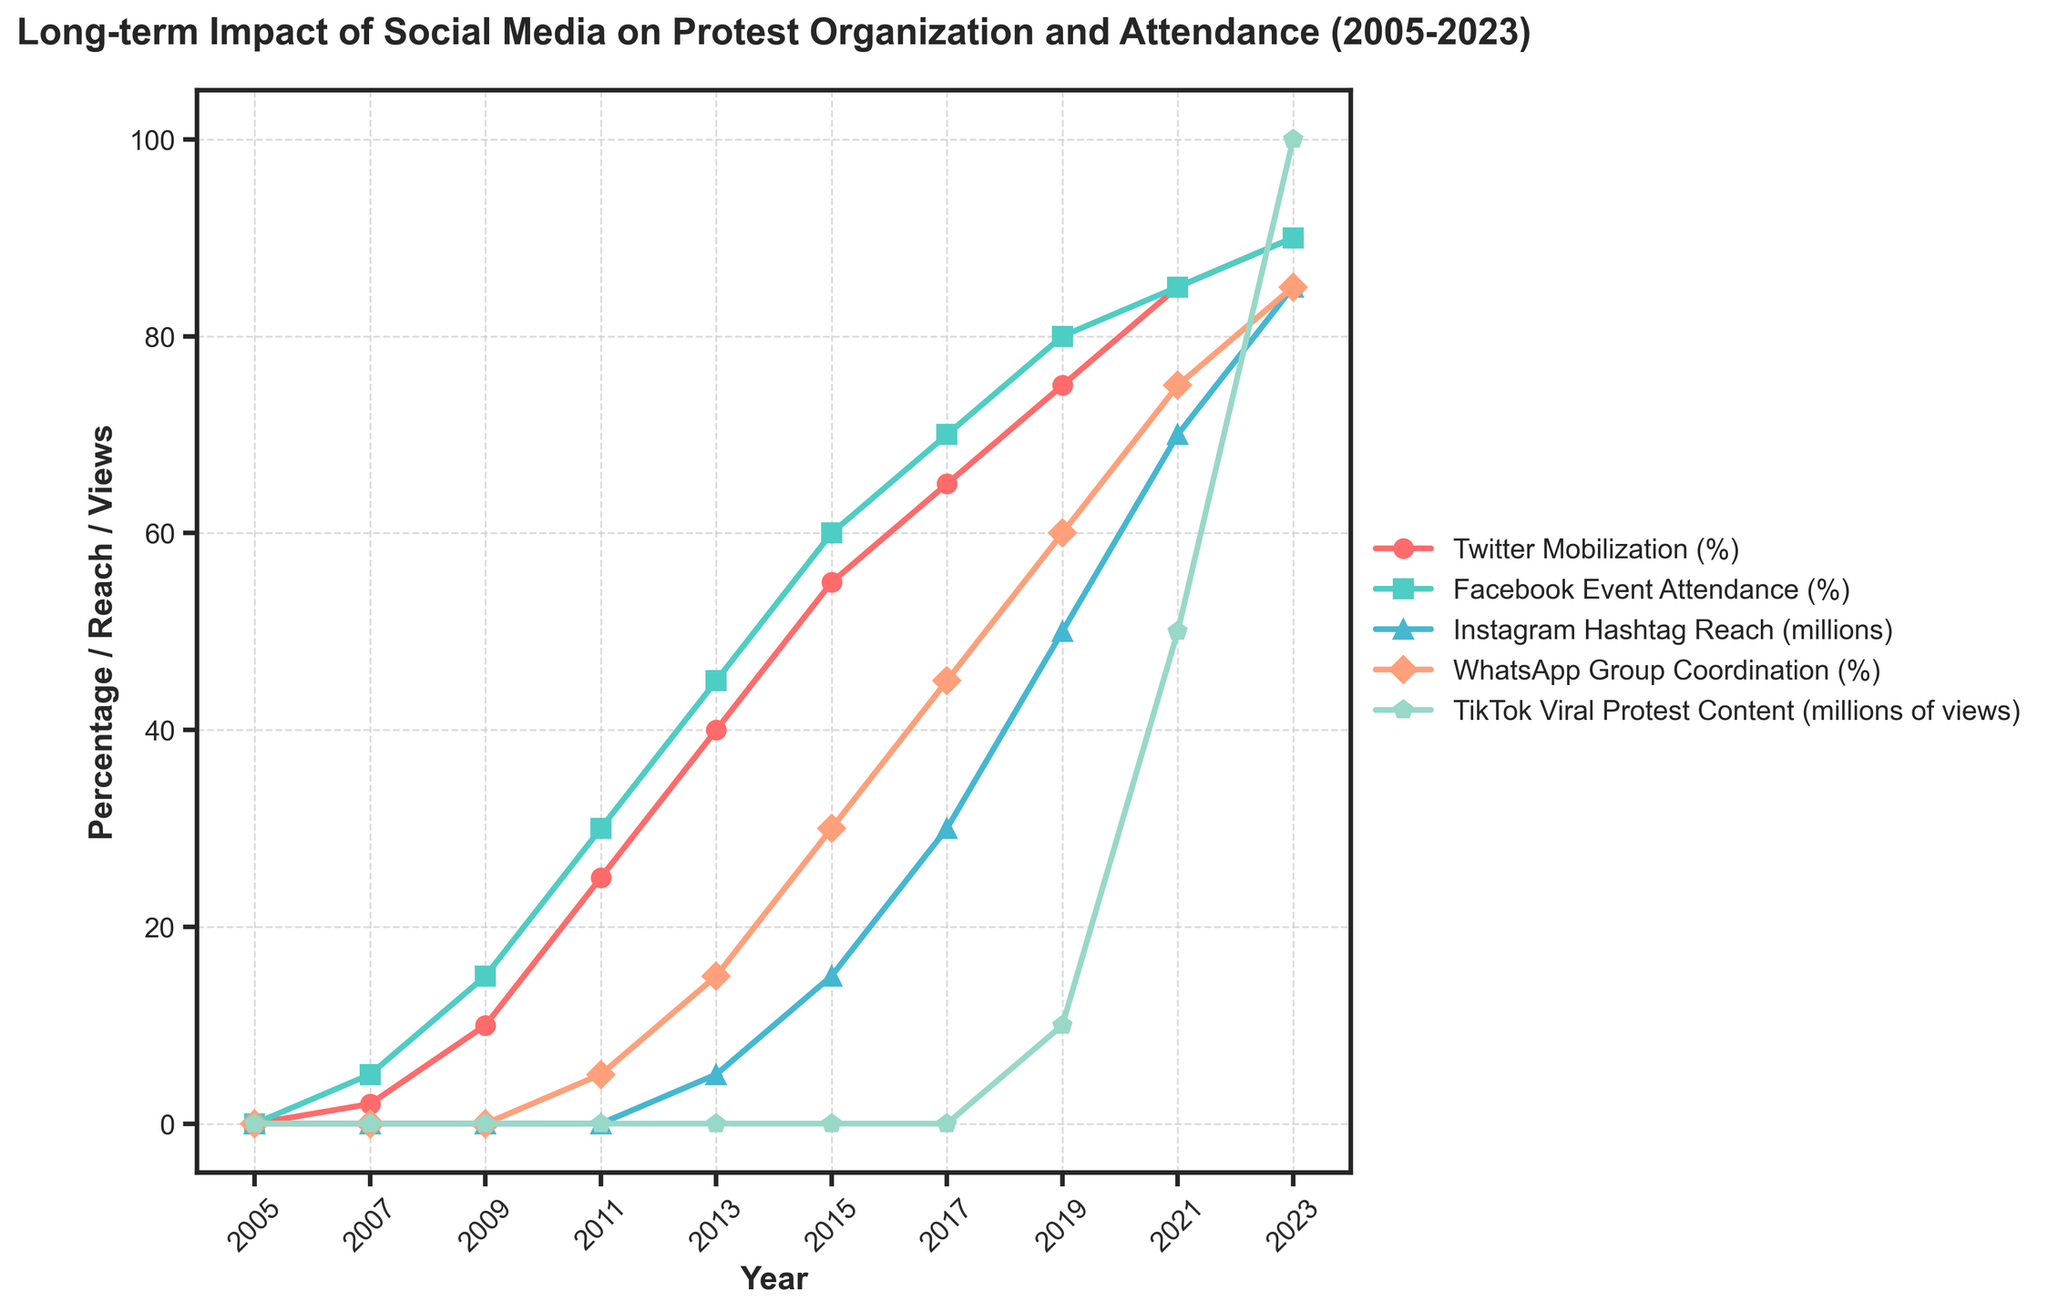What year did Instagram Hashtag Reach start to be tracked? Instagram Hashtag Reach started to show data in 2013. This can be seen by noting the first year with a non-zero value for the Instagram Hashtag Reach in the figure.
Answer: 2013 Which social media platform reached 90% mobilization by 2023? By observing the plot, we see that Twitter Mobilization and Facebook Event Attendance both reached 90% by 2023. The figure shows these platforms reaching the 90% mark on the y-axis for the year 2023.
Answer: Twitter Mobilization and Facebook Event Attendance What is the difference in Facebook Event Attendance between 2009 and 2013? In 2009, Facebook Event Attendance was 15%, and in 2013 it was 45%. The difference is calculated as 45% - 15% = 30%.
Answer: 30% How many years did it take for WhatsApp Group Coordination to reach 85% from 2011? WhatsApp Group Coordination was 5% in 2011 and reached 85% by 2023. The number of years between 2011 and 2023 is 2023 - 2011 = 12 years.
Answer: 12 years What was the average TikTok Viral Protest Content views in the years when it started showing data? TikTok Viral Protest Content started showing data in 2019 with 10 million views, and by 2023 it had 100 million views. The average is calculated by (10 + 100) / 2 = 55 million views.
Answer: 55 million views Which year showed the highest increase in Twitter Mobilization percentage? By visually tracing the steepest slope in the Twitter Mobilization line, we can see that the highest increase is between 2009 (10%) and 2011 (25%). The increase is 25% - 10% = 15%.
Answer: 2011 Compare the trends of WhatsApp Group Coordination and Instagram Hashtag Reach from 2013 to 2023. Which had a higher final value? Examining the lines, WhatsApp Group Coordination starts at 15% in 2013 and rises to 85% by 2023. Instagram Hashtag Reach starts at 5 million in 2013 and rises to 85 million by 2023. By simply comparing the final values directly indicated by the plot, WhatsApp Group Coordination has a higher final value of 85%.
Answer: WhatsApp Group Coordination Is there any year where all five methods displayed in the chart do not start from 0? According to the provided data, the first year where all methods (except TikTok) have non-zero values is 2009. TikTok data appear only in later years, beginning in 2019. So, considering all five methods, that specific condition doesn't fit perfectly. The correct year when all of them together plot data does not exist up to 2023.
Answer: No What is the longest duration where no change is observed in any of the platforms? The plot illustrates that from 2005 to 2007, most platforms maintained the same values (0), making it a duration of 2 years where little change was observed. Following this observation around 2 years (2005-2007) fits this criteria.
Answer: 2 years 